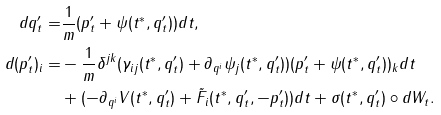<formula> <loc_0><loc_0><loc_500><loc_500>d q ^ { \prime } _ { t } = & \frac { 1 } { m } ( p _ { t } ^ { \prime } + \psi ( t ^ { * } , q _ { t } ^ { \prime } ) ) d t , \\ d ( p _ { t } ^ { \prime } ) _ { i } = & - \frac { 1 } { m } \delta ^ { j k } ( \gamma _ { i j } ( t ^ { * } , q _ { t } ^ { \prime } ) + \partial _ { q ^ { i } } \psi _ { j } ( t ^ { * } , q _ { t } ^ { \prime } ) ) ( p _ { t } ^ { \prime } + \psi ( t ^ { * } , q _ { t } ^ { \prime } ) ) _ { k } d t \\ & + ( - \partial _ { q ^ { i } } V ( t ^ { * } , q _ { t } ^ { \prime } ) + \tilde { F } _ { i } ( t ^ { * } , q _ { t } ^ { \prime } , - p _ { t } ^ { \prime } ) ) d t + \sigma ( t ^ { * } , q _ { t } ^ { \prime } ) \circ d W _ { t } .</formula> 